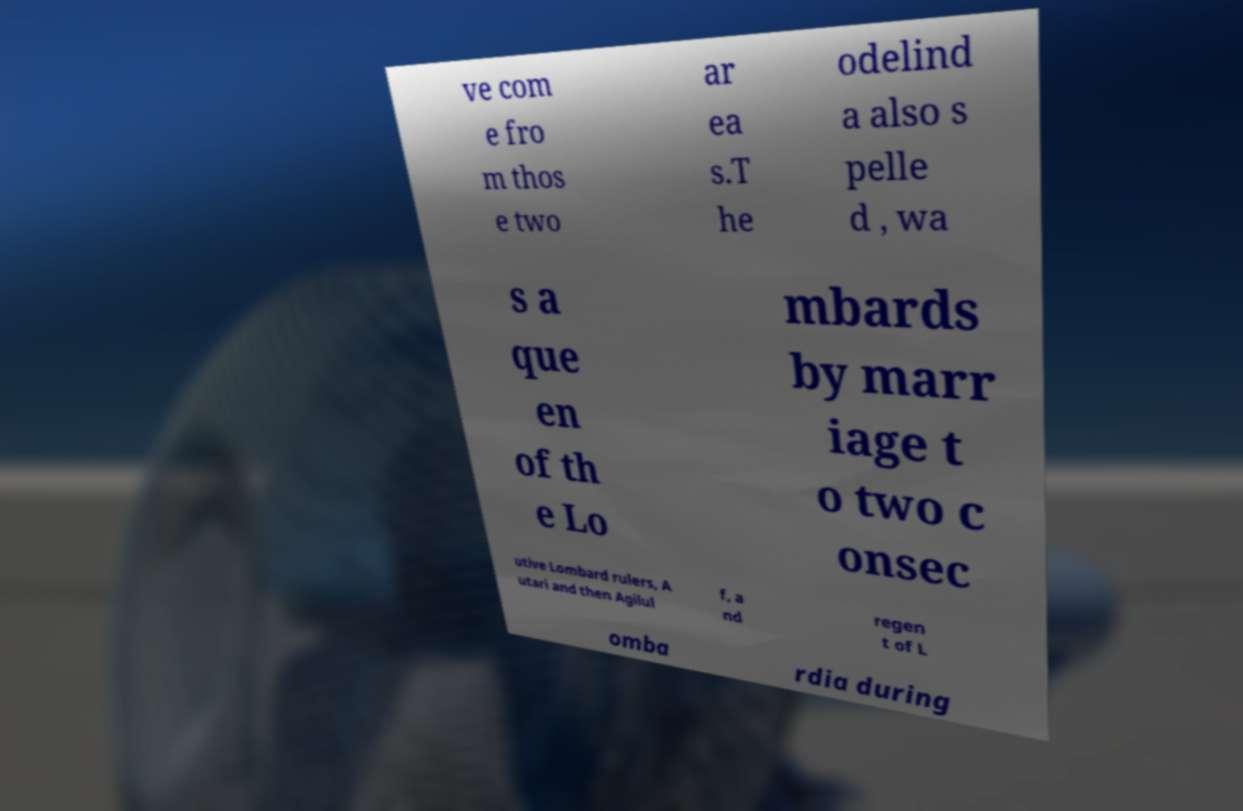Please identify and transcribe the text found in this image. ve com e fro m thos e two ar ea s.T he odelind a also s pelle d , wa s a que en of th e Lo mbards by marr iage t o two c onsec utive Lombard rulers, A utari and then Agilul f, a nd regen t of L omba rdia during 